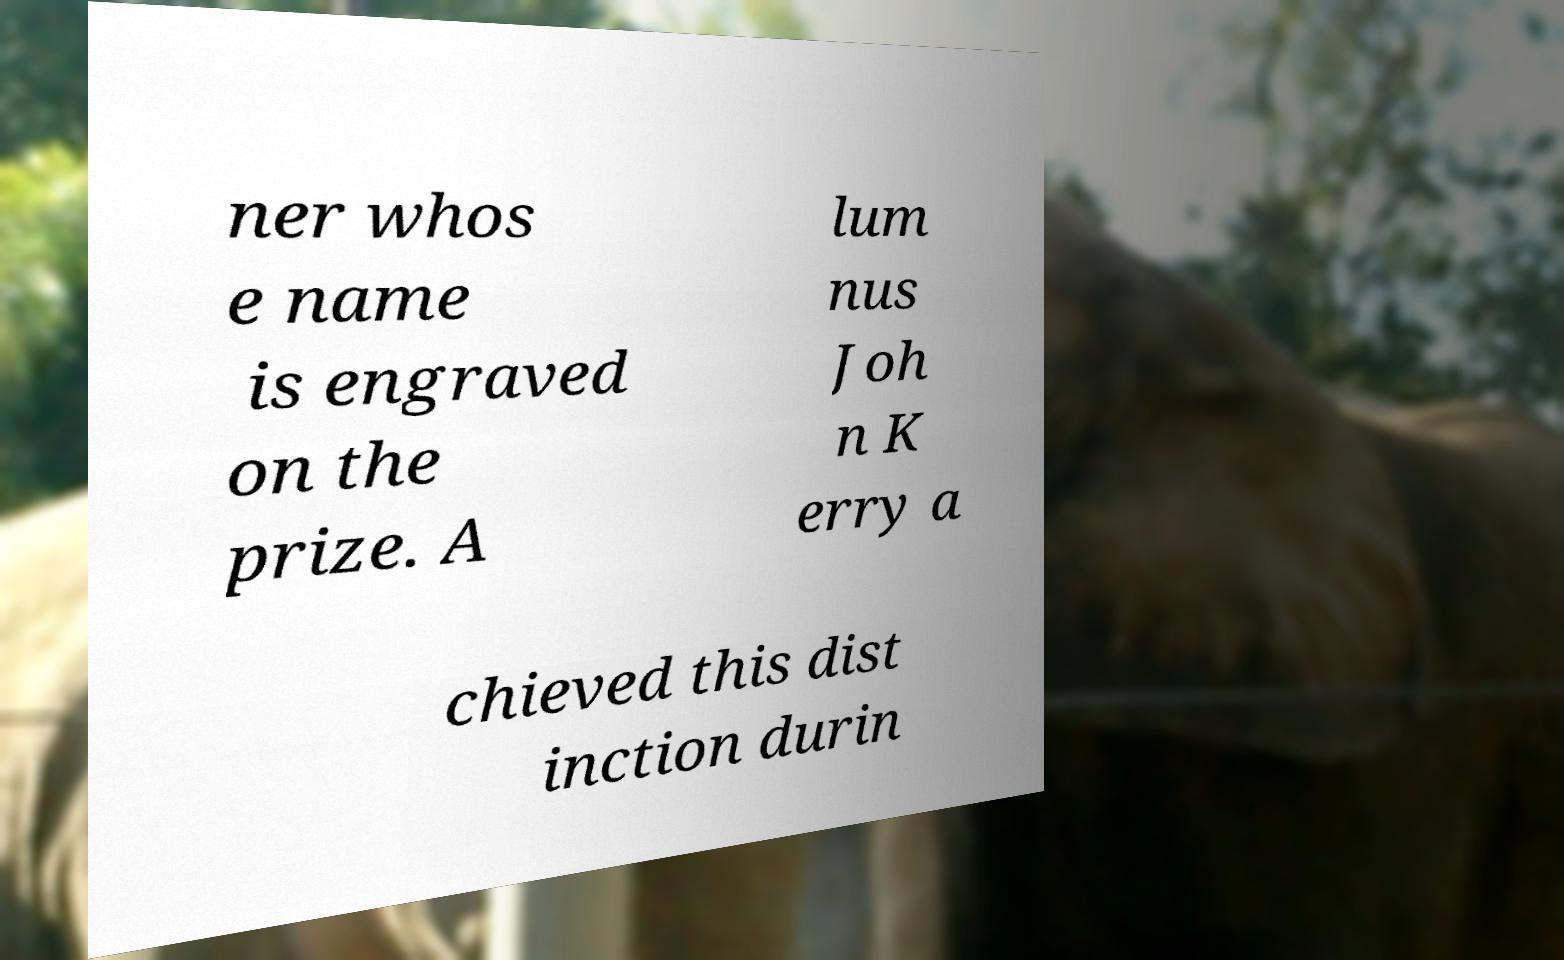Can you accurately transcribe the text from the provided image for me? ner whos e name is engraved on the prize. A lum nus Joh n K erry a chieved this dist inction durin 